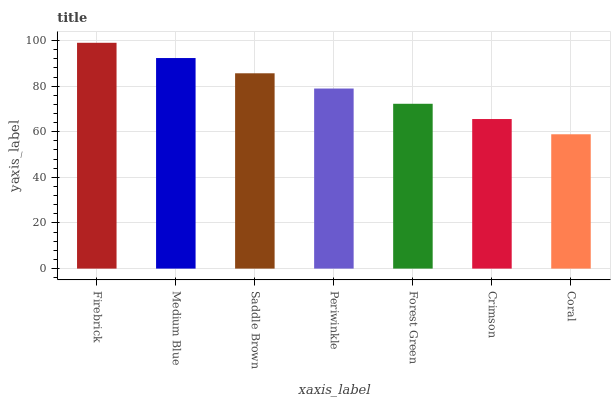Is Coral the minimum?
Answer yes or no. Yes. Is Firebrick the maximum?
Answer yes or no. Yes. Is Medium Blue the minimum?
Answer yes or no. No. Is Medium Blue the maximum?
Answer yes or no. No. Is Firebrick greater than Medium Blue?
Answer yes or no. Yes. Is Medium Blue less than Firebrick?
Answer yes or no. Yes. Is Medium Blue greater than Firebrick?
Answer yes or no. No. Is Firebrick less than Medium Blue?
Answer yes or no. No. Is Periwinkle the high median?
Answer yes or no. Yes. Is Periwinkle the low median?
Answer yes or no. Yes. Is Medium Blue the high median?
Answer yes or no. No. Is Saddle Brown the low median?
Answer yes or no. No. 